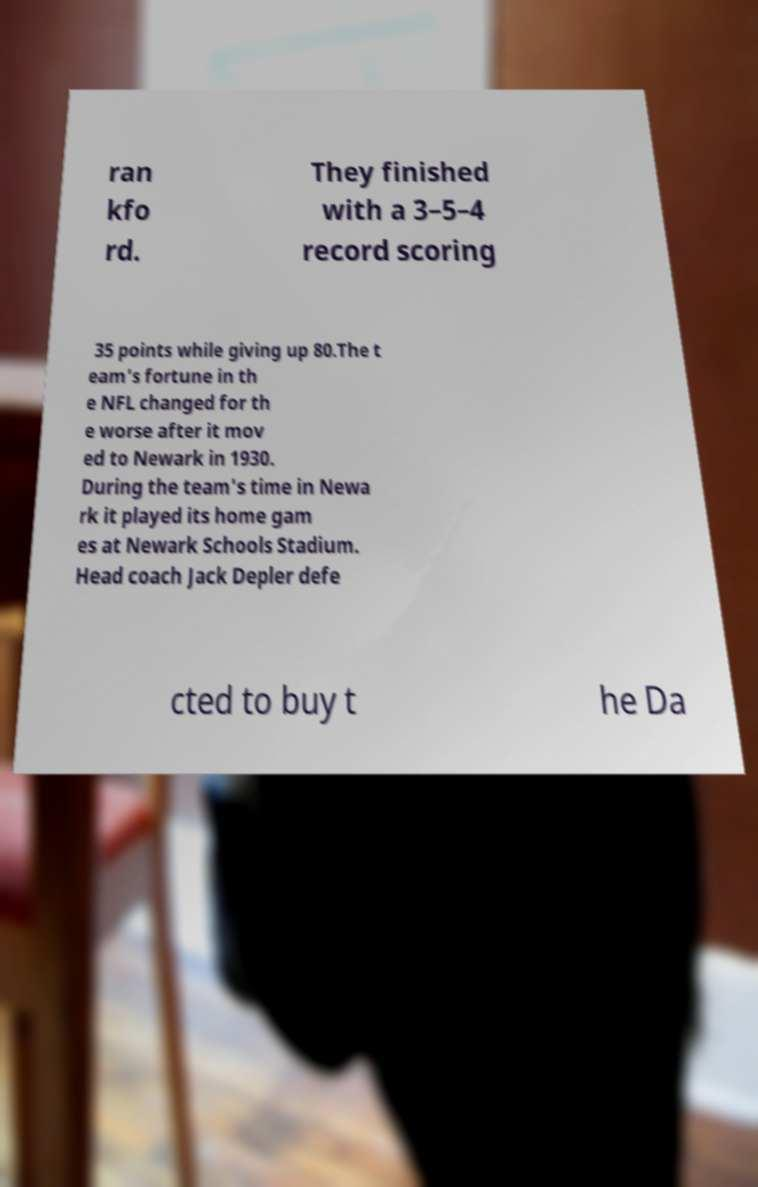Please identify and transcribe the text found in this image. ran kfo rd. They finished with a 3–5–4 record scoring 35 points while giving up 80.The t eam's fortune in th e NFL changed for th e worse after it mov ed to Newark in 1930. During the team's time in Newa rk it played its home gam es at Newark Schools Stadium. Head coach Jack Depler defe cted to buy t he Da 